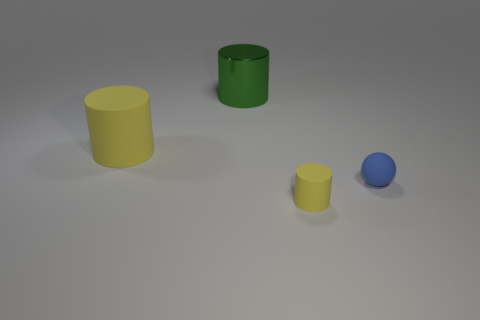What is the color of the cylinder on the left side of the large shiny cylinder?
Your answer should be compact. Yellow. What is the shape of the tiny blue thing?
Provide a succinct answer. Sphere. The yellow cylinder to the left of the yellow cylinder that is right of the large yellow matte cylinder is made of what material?
Keep it short and to the point. Rubber. What number of other objects are the same material as the large green object?
Your response must be concise. 0. There is another object that is the same size as the blue thing; what material is it?
Ensure brevity in your answer.  Rubber. Are there more green cylinders behind the big green metal cylinder than blue matte spheres that are on the left side of the large yellow cylinder?
Give a very brief answer. No. Are there any small green things that have the same shape as the blue matte thing?
Offer a terse response. No. The yellow rubber object that is the same size as the blue ball is what shape?
Ensure brevity in your answer.  Cylinder. There is a thing that is on the left side of the metallic cylinder; what shape is it?
Make the answer very short. Cylinder. Is the number of large matte cylinders that are behind the large green cylinder less than the number of yellow cylinders behind the small rubber ball?
Offer a terse response. Yes. 